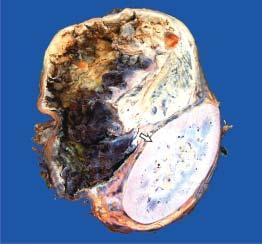does 2 and 3 show cystic change while solid areas show dark brown, necrotic and haemorrhagic tumour?
Answer the question using a single word or phrase. No 